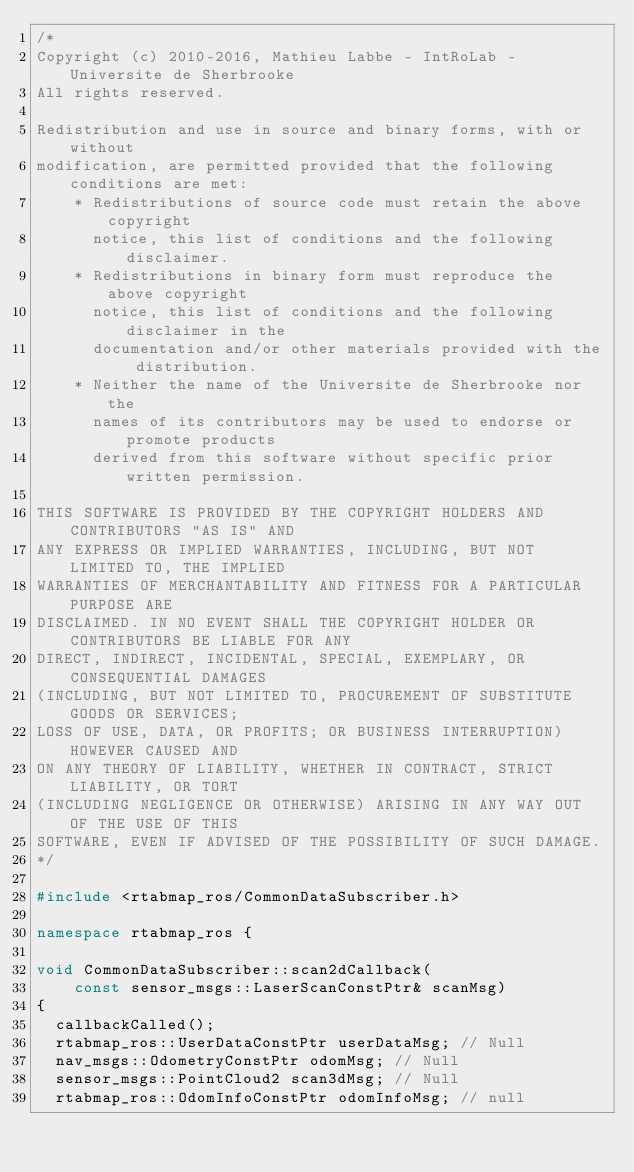Convert code to text. <code><loc_0><loc_0><loc_500><loc_500><_C++_>/*
Copyright (c) 2010-2016, Mathieu Labbe - IntRoLab - Universite de Sherbrooke
All rights reserved.

Redistribution and use in source and binary forms, with or without
modification, are permitted provided that the following conditions are met:
    * Redistributions of source code must retain the above copyright
      notice, this list of conditions and the following disclaimer.
    * Redistributions in binary form must reproduce the above copyright
      notice, this list of conditions and the following disclaimer in the
      documentation and/or other materials provided with the distribution.
    * Neither the name of the Universite de Sherbrooke nor the
      names of its contributors may be used to endorse or promote products
      derived from this software without specific prior written permission.

THIS SOFTWARE IS PROVIDED BY THE COPYRIGHT HOLDERS AND CONTRIBUTORS "AS IS" AND
ANY EXPRESS OR IMPLIED WARRANTIES, INCLUDING, BUT NOT LIMITED TO, THE IMPLIED
WARRANTIES OF MERCHANTABILITY AND FITNESS FOR A PARTICULAR PURPOSE ARE
DISCLAIMED. IN NO EVENT SHALL THE COPYRIGHT HOLDER OR CONTRIBUTORS BE LIABLE FOR ANY
DIRECT, INDIRECT, INCIDENTAL, SPECIAL, EXEMPLARY, OR CONSEQUENTIAL DAMAGES
(INCLUDING, BUT NOT LIMITED TO, PROCUREMENT OF SUBSTITUTE GOODS OR SERVICES;
LOSS OF USE, DATA, OR PROFITS; OR BUSINESS INTERRUPTION) HOWEVER CAUSED AND
ON ANY THEORY OF LIABILITY, WHETHER IN CONTRACT, STRICT LIABILITY, OR TORT
(INCLUDING NEGLIGENCE OR OTHERWISE) ARISING IN ANY WAY OUT OF THE USE OF THIS
SOFTWARE, EVEN IF ADVISED OF THE POSSIBILITY OF SUCH DAMAGE.
*/

#include <rtabmap_ros/CommonDataSubscriber.h>

namespace rtabmap_ros {

void CommonDataSubscriber::scan2dCallback(
		const sensor_msgs::LaserScanConstPtr& scanMsg)
{
	callbackCalled();
	rtabmap_ros::UserDataConstPtr userDataMsg; // Null
	nav_msgs::OdometryConstPtr odomMsg; // Null
	sensor_msgs::PointCloud2 scan3dMsg; // Null
	rtabmap_ros::OdomInfoConstPtr odomInfoMsg; // null</code> 